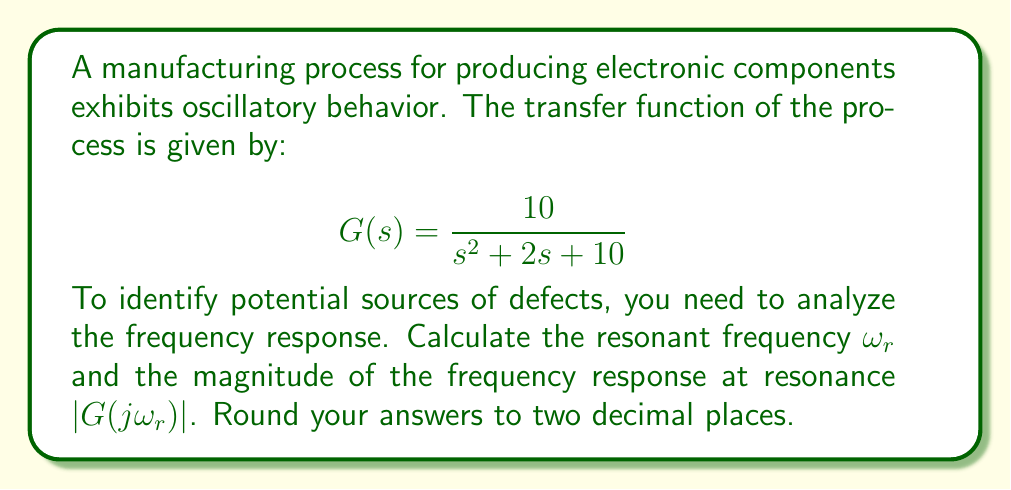Give your solution to this math problem. To analyze the frequency response and identify potential sources of defects, we need to follow these steps:

1) The general form of a second-order transfer function is:

   $$G(s) = \frac{\omega_n^2}{s^2 + 2\zeta\omega_n s + \omega_n^2}$$

   where $\omega_n$ is the natural frequency and $\zeta$ is the damping ratio.

2) Comparing our transfer function to the general form, we can identify:
   
   $\omega_n^2 = 10$, so $\omega_n = \sqrt{10} \approx 3.16$
   $2\zeta\omega_n = 2$, so $\zeta = \frac{1}{\sqrt{10}} \approx 0.316$

3) For an underdamped system ($\zeta < 1$), the resonant frequency $\omega_r$ is given by:

   $$\omega_r = \omega_n\sqrt{1 - 2\zeta^2}$$

4) Substituting the values:

   $$\omega_r = \sqrt{10}\sqrt{1 - 2(\frac{1}{\sqrt{10}})^2} = \sqrt{10}\sqrt{1 - \frac{2}{10}} = \sqrt{10}\sqrt{0.8} = \sqrt{8} \approx 2.83$$

5) To find the magnitude at resonance, we use the formula:

   $$|G(j\omega_r)| = \frac{1}{2\zeta\sqrt{1-\zeta^2}}$$

6) Substituting the value of $\zeta$:

   $$|G(j\omega_r)| = \frac{1}{2(\frac{1}{\sqrt{10}})\sqrt{1-(\frac{1}{\sqrt{10}})^2}} = \frac{\sqrt{10}}{2\sqrt{1-\frac{1}{10}}} = \frac{\sqrt{10}}{2\sqrt{0.9}} = \frac{\sqrt{10}}{2\sqrt{0.9}} \approx 1.58$$

The resonant frequency indicates where the process is most likely to amplify input variations, potentially leading to defects. The magnitude at resonance shows how much amplification occurs, with higher values indicating a greater risk of defects.
Answer: Resonant frequency $\omega_r \approx 2.83$ rad/s
Magnitude at resonance $|G(j\omega_r)| \approx 1.58$ 